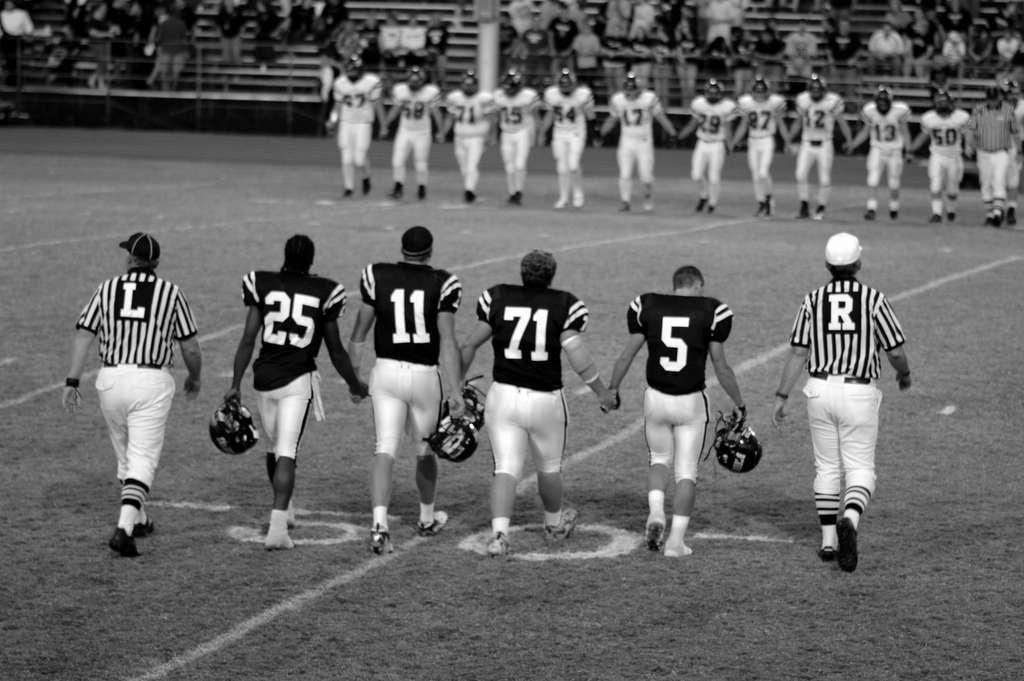<image>
Create a compact narrative representing the image presented. a ref with many others with the letter r on their outfit 